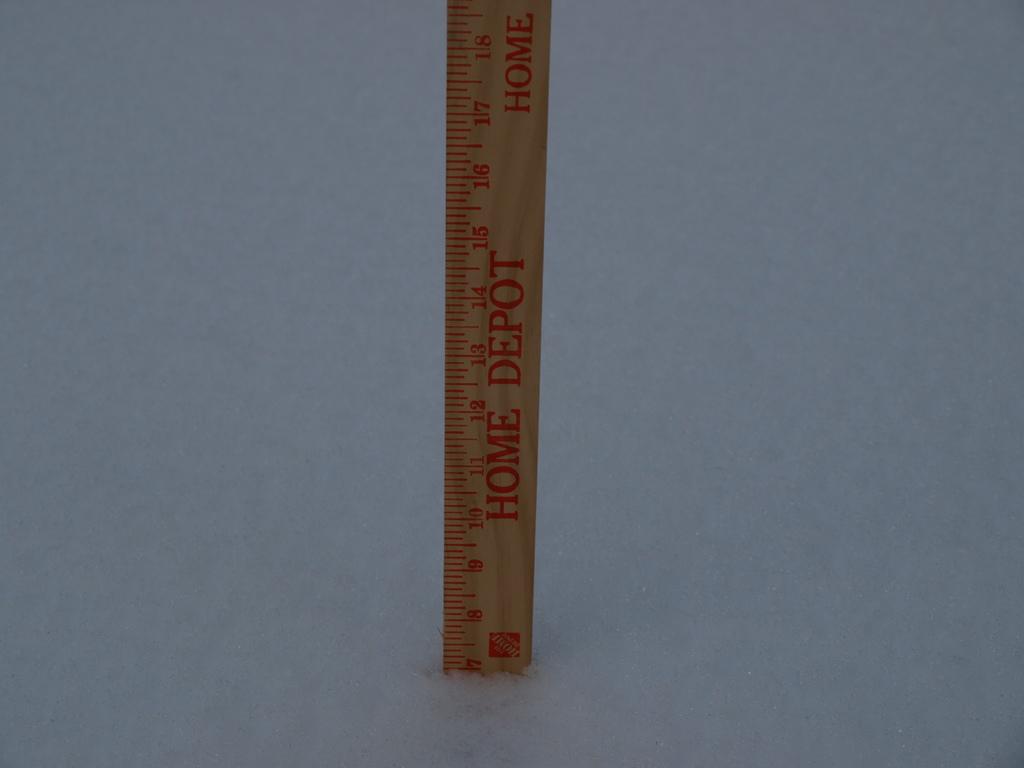Which company is this ruler from?
Offer a terse response. Home depot. What brand is the ruler?
Your response must be concise. Home depot. 